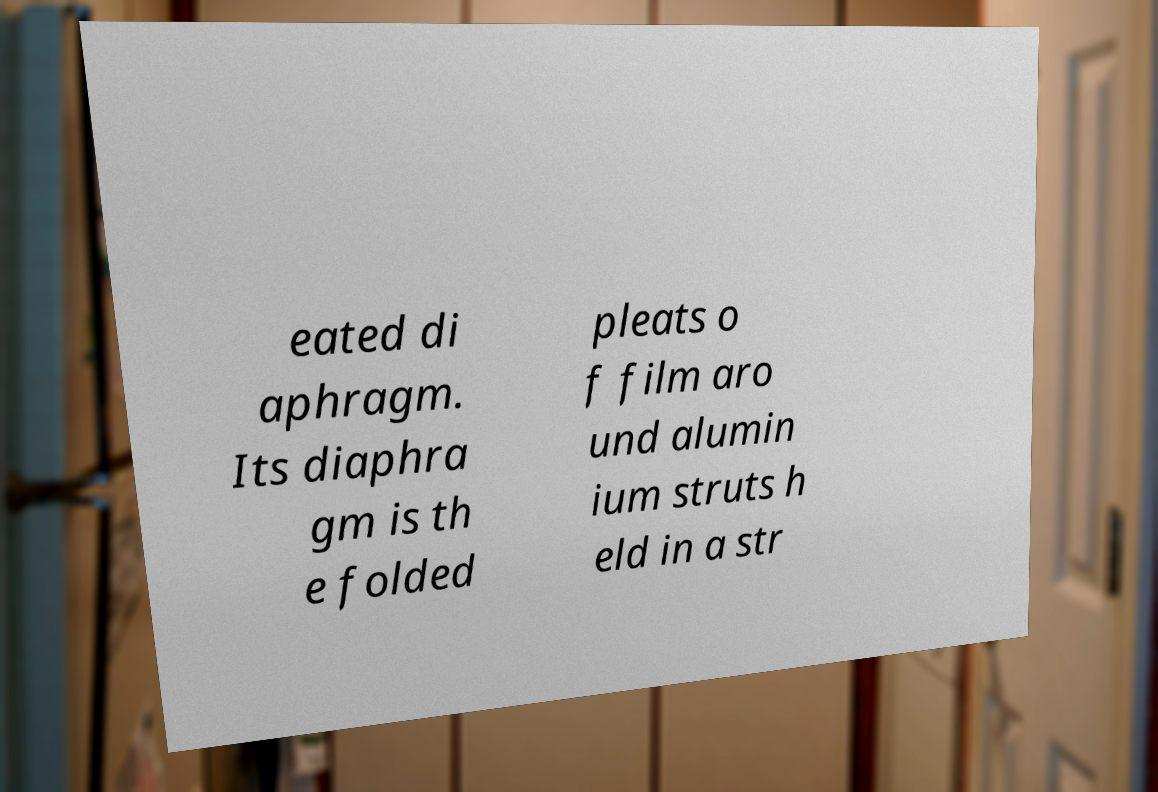Please identify and transcribe the text found in this image. eated di aphragm. Its diaphra gm is th e folded pleats o f film aro und alumin ium struts h eld in a str 